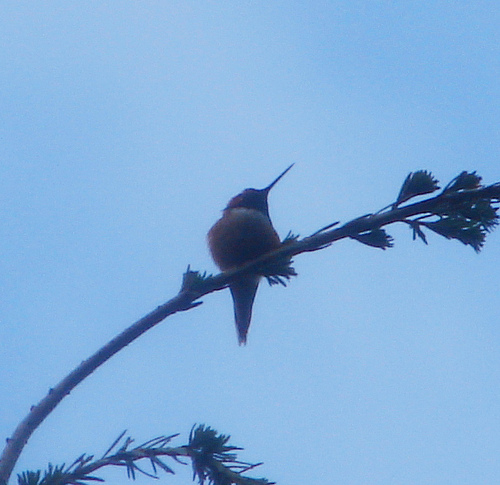<image>
Can you confirm if the bird is on the stick? Yes. Looking at the image, I can see the bird is positioned on top of the stick, with the stick providing support. 